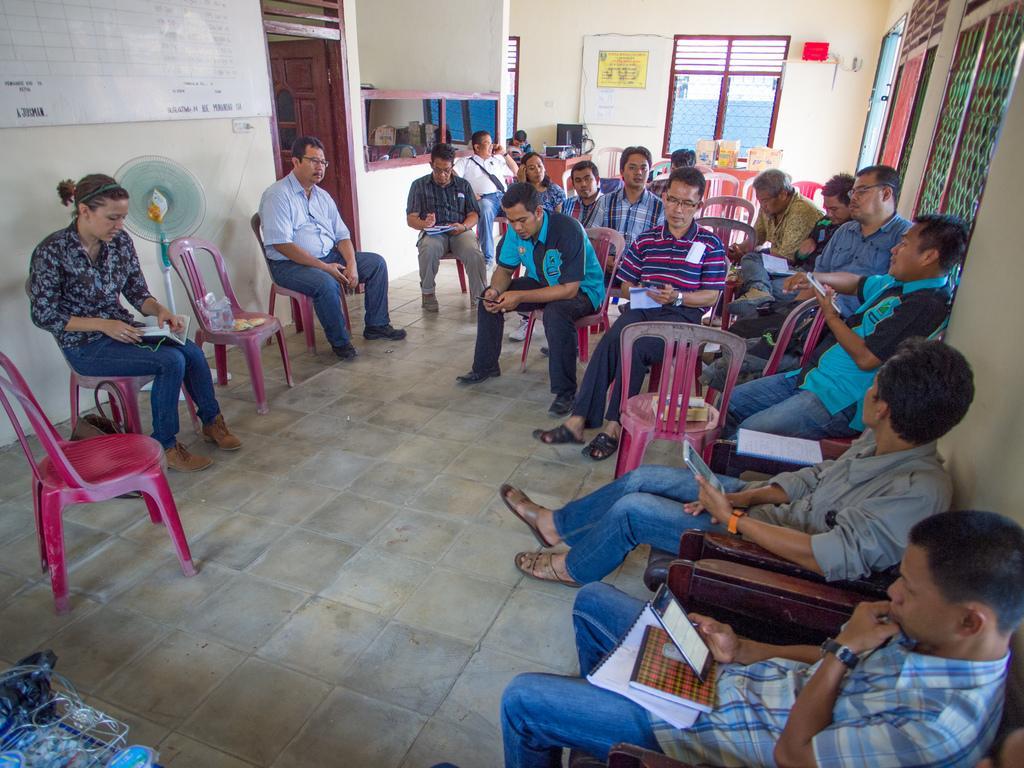Please provide a concise description of this image. The picture is inside a hall. people are sitting on chairs. They are having papers. the person on right is holding a phone. On the top right there is wall window. Here there is a door. In the top left there is white board. In the background there is window,table, notice board. 